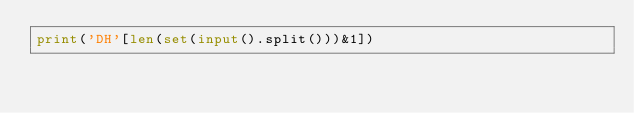<code> <loc_0><loc_0><loc_500><loc_500><_Python_>print('DH'[len(set(input().split()))&1])</code> 